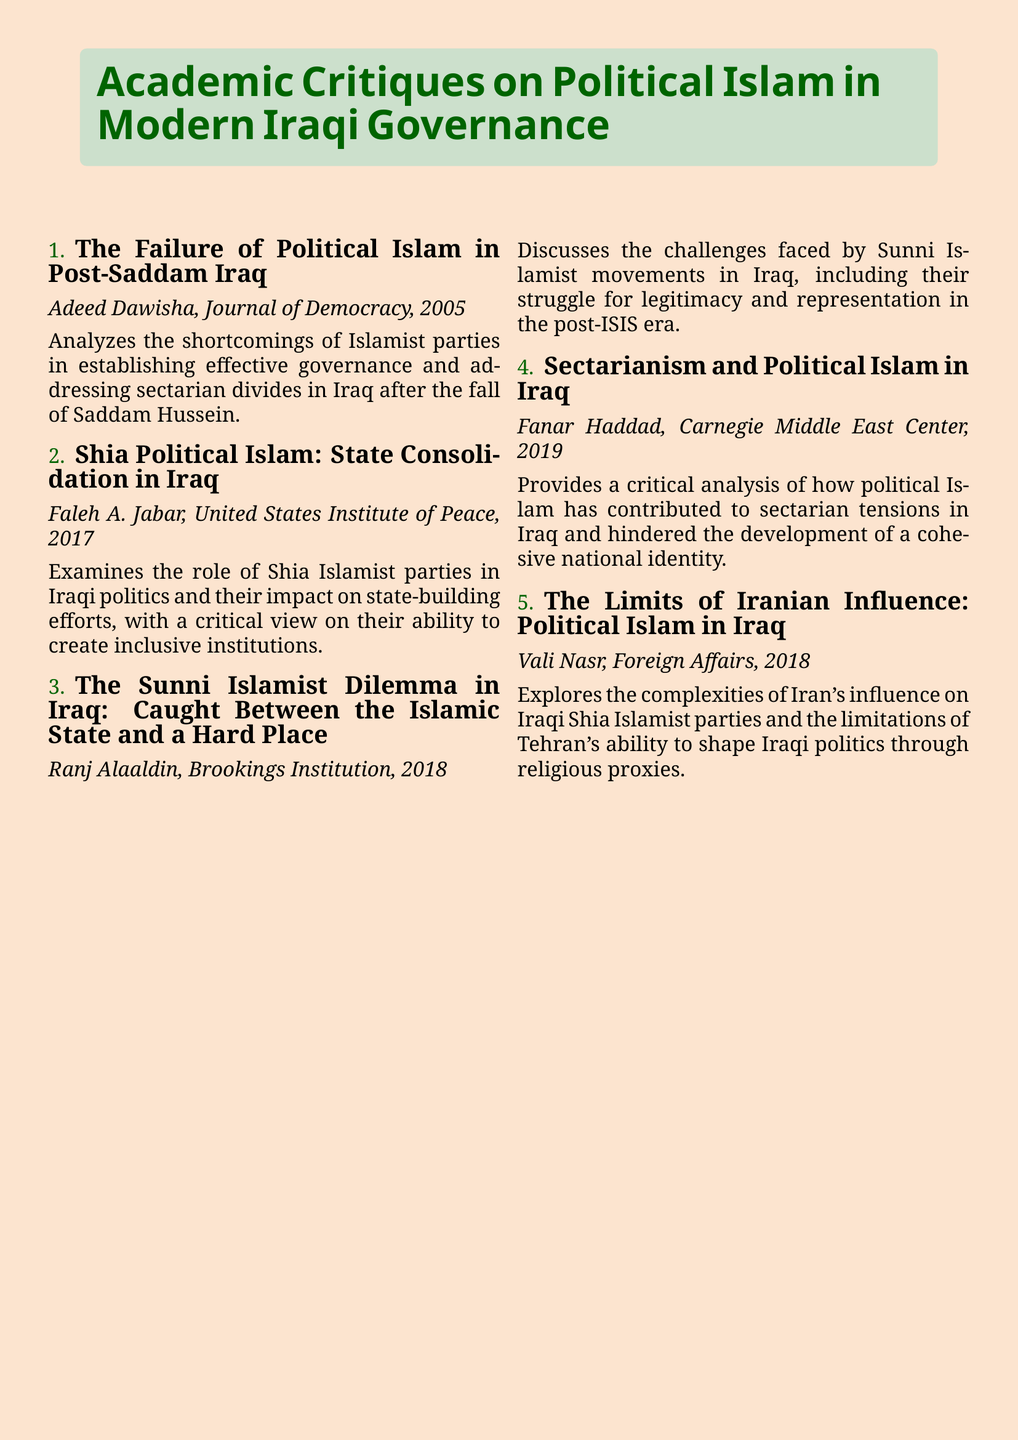What is the title of the first critique? The title of the first critique is listed in the enumerated section of the document.
Answer: The Failure of Political Islam in Post-Saddam Iraq Who wrote the critique on Shia Political Islam in Iraq? The author's name is presented alongside the title of the critique.
Answer: Faleh A. Jabar In what year was "The Sunni Islamist Dilemma in Iraq" published? The publication year can be found next to the critique's title in the document.
Answer: 2018 How many critiques focus specifically on Islamist parties in Iraq? The total number can be counted from the enumerated list of critiques.
Answer: Four What major theme is explored in "Sectarianism and Political Islam in Iraq"? The theme is indicated in the title and can be inferred from the description.
Answer: Sectarian tensions Which publication contains the critique about Iranian influence on Iraqi politics? The name of the publication is stated next to the author in the description.
Answer: Foreign Affairs What is the main focus of Adeed Dawisha's critique? The main focus can be deduced from the title and the summary provided.
Answer: Shortcomings of Islamist parties Who is the author of the critique that discusses sectarianism? The author's name is mentioned in the document adjacent to the critique title.
Answer: Fanar Haddad 